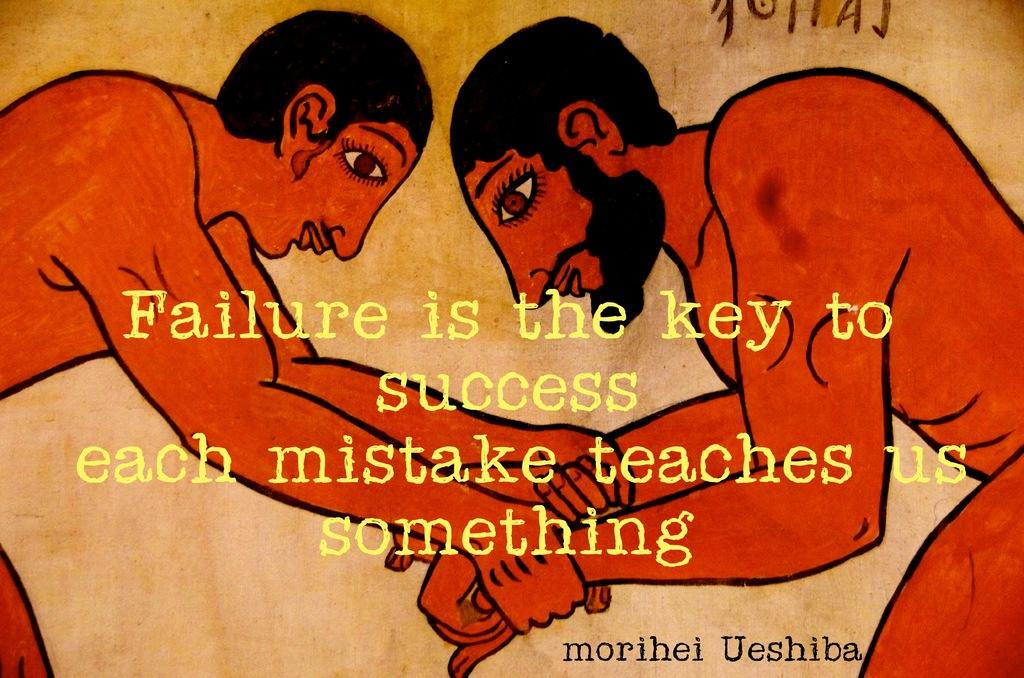What is the main subject of the image? The main subject of the image is an art piece. What elements are included in the art piece? The art piece contains persons and text. What type of zephyr is depicted in the art piece? There is no zephyr present in the image or art piece. Who is the manager of the persons depicted in the art piece? There is no indication of a manager or any hierarchical structure among the persons depicted in the art piece. 